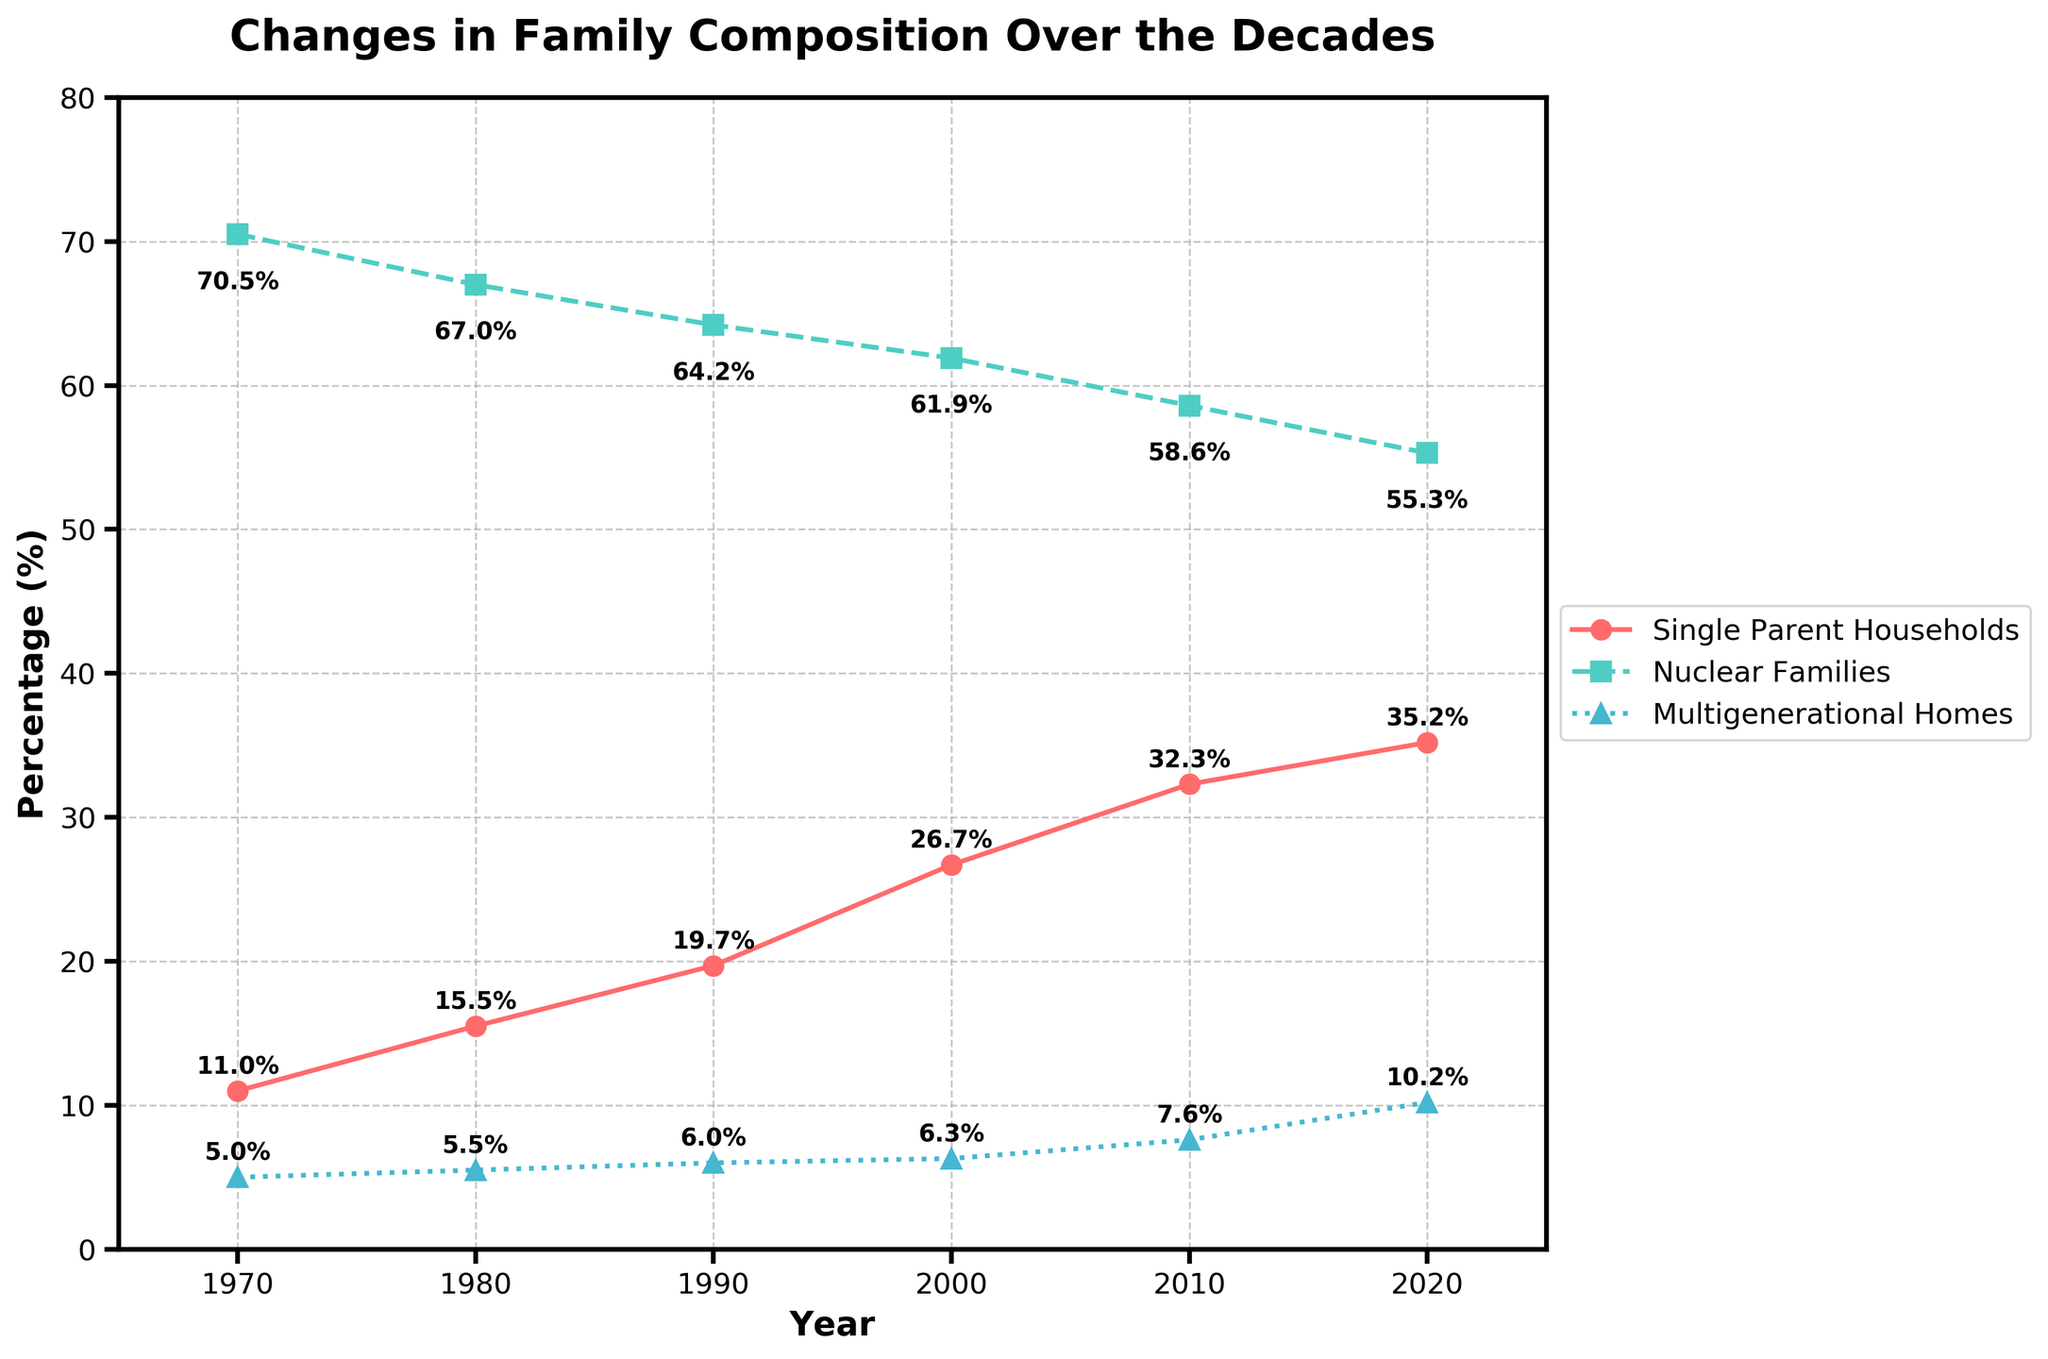What is the title of the plot? The title is located at the top center of the plot in bold text. It clearly states what the plot is about.
Answer: Changes in Family Composition Over the Decades How many types of family compositions are tracked in the plot? By observing the legend on the right side of the plot, we can count the number of different family compositions.
Answer: 3 Which family composition has the highest percentage in 1970? Look at the percentages for each family composition in the year 1970. The highest percentage corresponds to the nuclear families.
Answer: Nuclear Families What trend is observed in the percentage of single-parent households from 1970 to 2020? By looking at the trend line for single-parent households, it shows a general increase over the years.
Answer: Increasing What is the percentage change for multigenerational homes from 2000 to 2020? Calculate the difference in the percentage of multigenerational homes between 2000 (6.3%) and 2020 (10.2%) by subtracting the initial value from the final value. (10.2% - 6.3%) = 3.9%.
Answer: 3.9% Which year shows the largest difference between nuclear families and single-parent households? Calculate the differences for each year: 1970 (70.5 - 11.0 = 59.5), 1980 (67.0 - 15.5 = 51.5), 1990 (64.2 - 19.7 = 44.5), 2000 (61.9 - 26.7 = 35.2), 2010 (58.6 - 32.3 = 26.3), 2020 (55.3 - 35.2 = 20.1). The largest difference is in 1970.
Answer: 1970 Has the percentage of nuclear families ever risen over the decades? Trace the trend line for nuclear families from 1970 to 2020, and observe that it continuously decreases without any rise.
Answer: No In which decade did multigenerational homes surpass 7%? Look at the trend line for multigenerational homes and identify the point where it crosses the 7% mark, which is between 2000 (6.3%) and 2010 (7.6%).
Answer: 2000s How has the percentage of nuclear families changed from 1970 to 2020? Calculate the difference between the percentage in 1970 (70.5%) and in 2020 (55.3%) by subtracting the later value from the former. (70.5 - 55.3) = 15.2%.
Answer: Decreased by 15.2% Which family composition shows the most significant change in percentage over the entire period? Compare the changes in percentages from 1970 to 2020 for each family composition: Single-Parent (35.2 - 11.0 = 24.2), Nuclear Families (70.5 - 55.3 = 15.2), Multigenerational Homes (10.2 - 5.0 = 5.2). The Single-Parent Households show the most significant change.
Answer: Single-Parent Households 